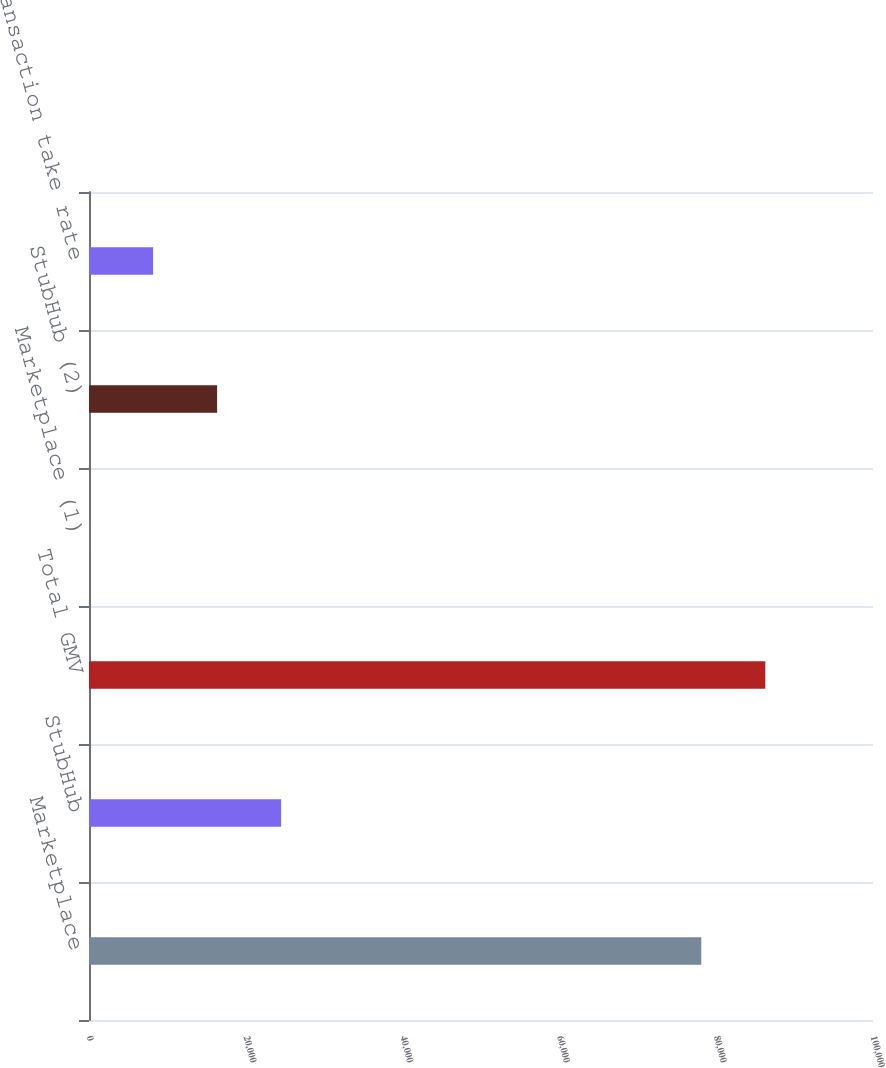Convert chart. <chart><loc_0><loc_0><loc_500><loc_500><bar_chart><fcel>Marketplace<fcel>StubHub<fcel>Total GMV<fcel>Marketplace (1)<fcel>StubHub (2)<fcel>Total transaction take rate<nl><fcel>78099<fcel>24507.4<fcel>86265.5<fcel>7.81<fcel>16340.9<fcel>8174.33<nl></chart> 